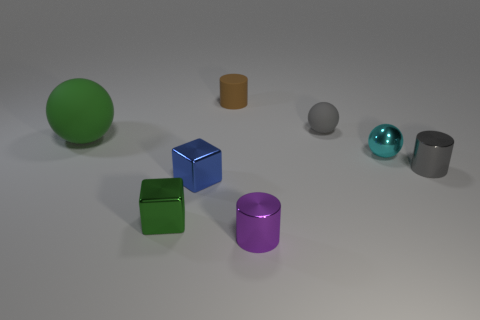Add 2 cyan things. How many objects exist? 10 Subtract all cylinders. How many objects are left? 5 Add 4 small blue cubes. How many small blue cubes exist? 5 Subtract 0 gray cubes. How many objects are left? 8 Subtract all small cyan matte balls. Subtract all tiny cyan spheres. How many objects are left? 7 Add 7 metallic cylinders. How many metallic cylinders are left? 9 